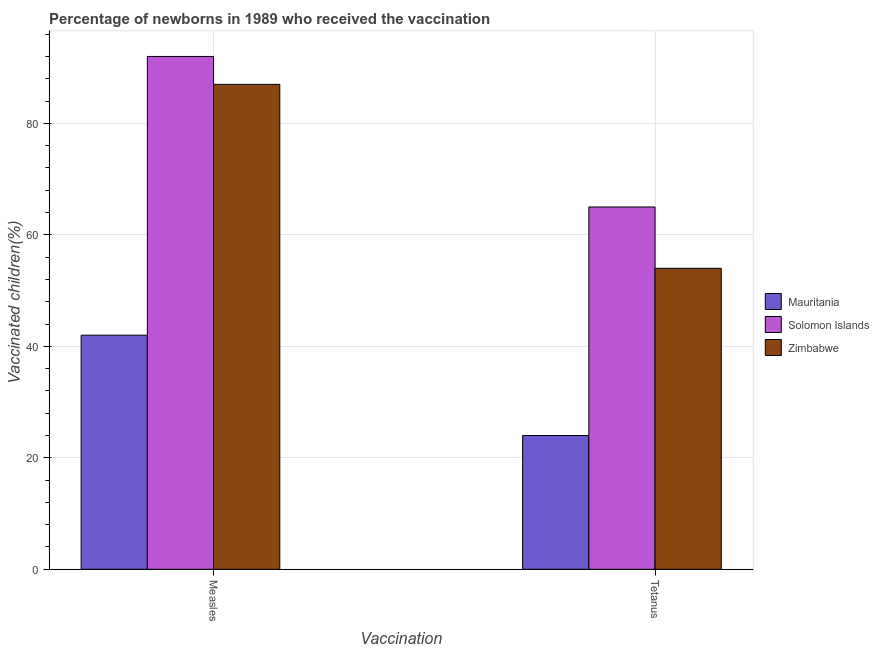Are the number of bars per tick equal to the number of legend labels?
Your answer should be very brief. Yes. Are the number of bars on each tick of the X-axis equal?
Offer a terse response. Yes. How many bars are there on the 2nd tick from the left?
Provide a short and direct response. 3. What is the label of the 2nd group of bars from the left?
Give a very brief answer. Tetanus. What is the percentage of newborns who received vaccination for tetanus in Mauritania?
Provide a succinct answer. 24. Across all countries, what is the maximum percentage of newborns who received vaccination for tetanus?
Your answer should be very brief. 65. Across all countries, what is the minimum percentage of newborns who received vaccination for tetanus?
Offer a very short reply. 24. In which country was the percentage of newborns who received vaccination for measles maximum?
Provide a short and direct response. Solomon Islands. In which country was the percentage of newborns who received vaccination for measles minimum?
Your answer should be very brief. Mauritania. What is the total percentage of newborns who received vaccination for measles in the graph?
Give a very brief answer. 221. What is the difference between the percentage of newborns who received vaccination for tetanus in Mauritania and that in Zimbabwe?
Provide a succinct answer. -30. What is the difference between the percentage of newborns who received vaccination for tetanus in Mauritania and the percentage of newborns who received vaccination for measles in Zimbabwe?
Your response must be concise. -63. What is the average percentage of newborns who received vaccination for tetanus per country?
Make the answer very short. 47.67. What is the difference between the percentage of newborns who received vaccination for tetanus and percentage of newborns who received vaccination for measles in Mauritania?
Provide a short and direct response. -18. What is the ratio of the percentage of newborns who received vaccination for tetanus in Solomon Islands to that in Zimbabwe?
Make the answer very short. 1.2. In how many countries, is the percentage of newborns who received vaccination for tetanus greater than the average percentage of newborns who received vaccination for tetanus taken over all countries?
Provide a short and direct response. 2. What does the 3rd bar from the left in Tetanus represents?
Your answer should be compact. Zimbabwe. What does the 1st bar from the right in Measles represents?
Your response must be concise. Zimbabwe. How many bars are there?
Provide a succinct answer. 6. How many countries are there in the graph?
Your response must be concise. 3. Are the values on the major ticks of Y-axis written in scientific E-notation?
Your answer should be very brief. No. Does the graph contain any zero values?
Provide a short and direct response. No. Does the graph contain grids?
Offer a very short reply. Yes. Where does the legend appear in the graph?
Provide a succinct answer. Center right. How many legend labels are there?
Provide a succinct answer. 3. What is the title of the graph?
Your answer should be very brief. Percentage of newborns in 1989 who received the vaccination. Does "Tunisia" appear as one of the legend labels in the graph?
Offer a terse response. No. What is the label or title of the X-axis?
Give a very brief answer. Vaccination. What is the label or title of the Y-axis?
Your answer should be very brief. Vaccinated children(%)
. What is the Vaccinated children(%)
 in Solomon Islands in Measles?
Your answer should be compact. 92. What is the Vaccinated children(%)
 in Mauritania in Tetanus?
Provide a succinct answer. 24. Across all Vaccination, what is the maximum Vaccinated children(%)
 in Solomon Islands?
Ensure brevity in your answer.  92. Across all Vaccination, what is the maximum Vaccinated children(%)
 in Zimbabwe?
Give a very brief answer. 87. Across all Vaccination, what is the minimum Vaccinated children(%)
 in Mauritania?
Offer a terse response. 24. Across all Vaccination, what is the minimum Vaccinated children(%)
 in Solomon Islands?
Your answer should be compact. 65. What is the total Vaccinated children(%)
 of Mauritania in the graph?
Provide a succinct answer. 66. What is the total Vaccinated children(%)
 in Solomon Islands in the graph?
Provide a succinct answer. 157. What is the total Vaccinated children(%)
 in Zimbabwe in the graph?
Give a very brief answer. 141. What is the difference between the Vaccinated children(%)
 in Mauritania in Measles and that in Tetanus?
Make the answer very short. 18. What is the difference between the Vaccinated children(%)
 of Solomon Islands in Measles and that in Tetanus?
Make the answer very short. 27. What is the average Vaccinated children(%)
 in Mauritania per Vaccination?
Your answer should be very brief. 33. What is the average Vaccinated children(%)
 in Solomon Islands per Vaccination?
Give a very brief answer. 78.5. What is the average Vaccinated children(%)
 of Zimbabwe per Vaccination?
Offer a terse response. 70.5. What is the difference between the Vaccinated children(%)
 of Mauritania and Vaccinated children(%)
 of Solomon Islands in Measles?
Your answer should be compact. -50. What is the difference between the Vaccinated children(%)
 of Mauritania and Vaccinated children(%)
 of Zimbabwe in Measles?
Your answer should be very brief. -45. What is the difference between the Vaccinated children(%)
 in Mauritania and Vaccinated children(%)
 in Solomon Islands in Tetanus?
Provide a succinct answer. -41. What is the difference between the Vaccinated children(%)
 of Solomon Islands and Vaccinated children(%)
 of Zimbabwe in Tetanus?
Provide a succinct answer. 11. What is the ratio of the Vaccinated children(%)
 in Mauritania in Measles to that in Tetanus?
Your response must be concise. 1.75. What is the ratio of the Vaccinated children(%)
 in Solomon Islands in Measles to that in Tetanus?
Your response must be concise. 1.42. What is the ratio of the Vaccinated children(%)
 in Zimbabwe in Measles to that in Tetanus?
Provide a short and direct response. 1.61. What is the difference between the highest and the lowest Vaccinated children(%)
 of Solomon Islands?
Provide a short and direct response. 27. 